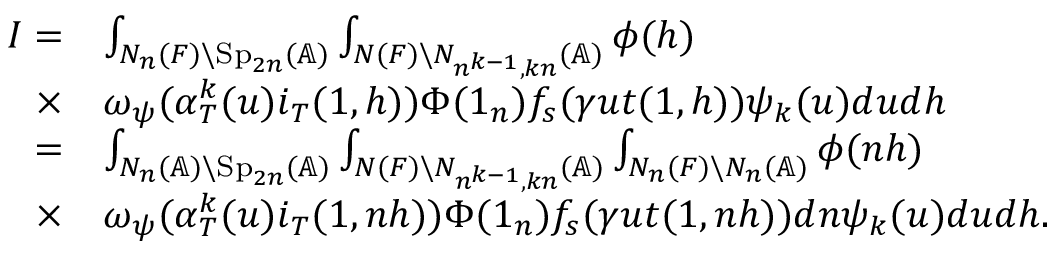<formula> <loc_0><loc_0><loc_500><loc_500>\begin{array} { r l } { I = } & { \int _ { N _ { n } ( F ) \ S p _ { 2 n } ( \mathbb { A } ) } \int _ { N ( F ) \ N _ { n ^ { k - 1 } , k n } ( \mathbb { A } ) } \phi ( h ) } \\ { \times } & { \omega _ { \psi } ( \alpha _ { T } ^ { k } ( u ) i _ { T } ( 1 , h ) ) \Phi ( 1 _ { n } ) f _ { s } ( \gamma u t ( 1 , h ) ) \psi _ { k } ( u ) d u d h } \\ { = } & { \int _ { N _ { n } ( \mathbb { A } ) \ S p _ { 2 n } ( \mathbb { A } ) } \int _ { N ( F ) \ N _ { n ^ { k - 1 } , k n } ( \mathbb { A } ) } \int _ { N _ { n } ( F ) \ N _ { n } ( \mathbb { A } ) } \phi ( n h ) } \\ { \times } & { \omega _ { \psi } ( \alpha _ { T } ^ { k } ( u ) i _ { T } ( 1 , n h ) ) \Phi ( 1 _ { n } ) f _ { s } ( \gamma u t ( 1 , n h ) ) d n \psi _ { k } ( u ) d u d h . } \end{array}</formula> 